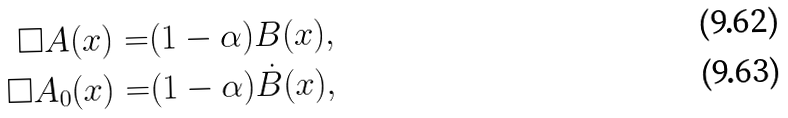Convert formula to latex. <formula><loc_0><loc_0><loc_500><loc_500>\square A ( x ) = & ( 1 - \alpha ) B ( x ) , \\ \square A _ { 0 } ( x ) = & ( 1 - \alpha ) \dot { B } ( x ) ,</formula> 